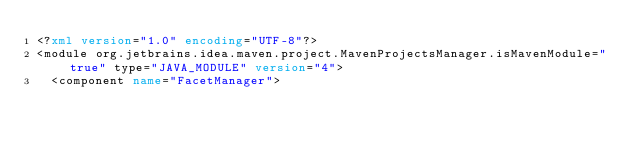Convert code to text. <code><loc_0><loc_0><loc_500><loc_500><_XML_><?xml version="1.0" encoding="UTF-8"?>
<module org.jetbrains.idea.maven.project.MavenProjectsManager.isMavenModule="true" type="JAVA_MODULE" version="4">
  <component name="FacetManager"></code> 